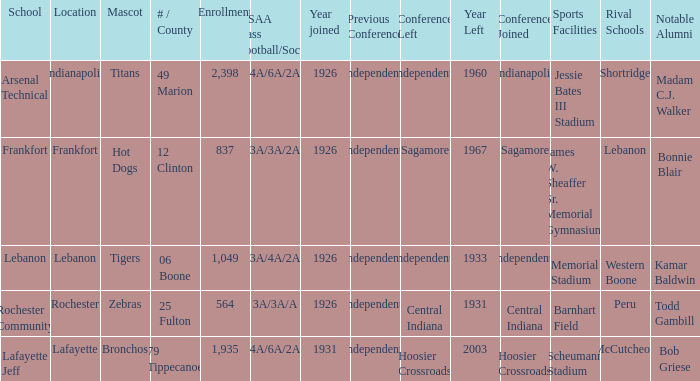What is the average enrollment that has hot dogs as the mascot, with a year joined later than 1926? None. Would you be able to parse every entry in this table? {'header': ['School', 'Location', 'Mascot', '# / County', 'Enrollment', 'IHSAA Class /Football/Soccer', 'Year joined', 'Previous Conference', 'Conference Left', 'Year Left', 'Conference Joined', 'Sports Facilities', 'Rival Schools', 'Notable Alumni'], 'rows': [['Arsenal Technical', 'Indianapolis', 'Titans', '49 Marion', '2,398', '4A/6A/2A', '1926', 'Independents', 'Independents', '1960', 'Indianapolis', 'Jessie Bates III Stadium', 'Shortridge', 'Madam C.J. Walker'], ['Frankfort', 'Frankfort', 'Hot Dogs', '12 Clinton', '837', '3A/3A/2A', '1926', 'Independents', 'Sagamore', '1967', 'Sagamore', 'James W. Sheaffer Sr. Memorial Gymnasium', 'Lebanon', 'Bonnie Blair'], ['Lebanon', 'Lebanon', 'Tigers', '06 Boone', '1,049', '3A/4A/2A', '1926', 'Independents', 'Independents', '1933', 'Independents', 'Memorial Stadium', 'Western Boone', 'Kamar Baldwin'], ['Rochester Community', 'Rochester', 'Zebras', '25 Fulton', '564', '3A/3A/A', '1926', 'Independents', 'Central Indiana', '1931', 'Central Indiana', 'Barnhart Field', 'Peru', 'Todd Gambill'], ['Lafayette Jeff', 'Lafayette', 'Bronchos', '79 Tippecanoe', '1,935', '4A/6A/2A', '1931', 'Independents', 'Hoosier Crossroads', '2003', 'Hoosier Crossroads', 'Scheumann Stadium', 'McCutcheon', 'Bob Griese']]} 